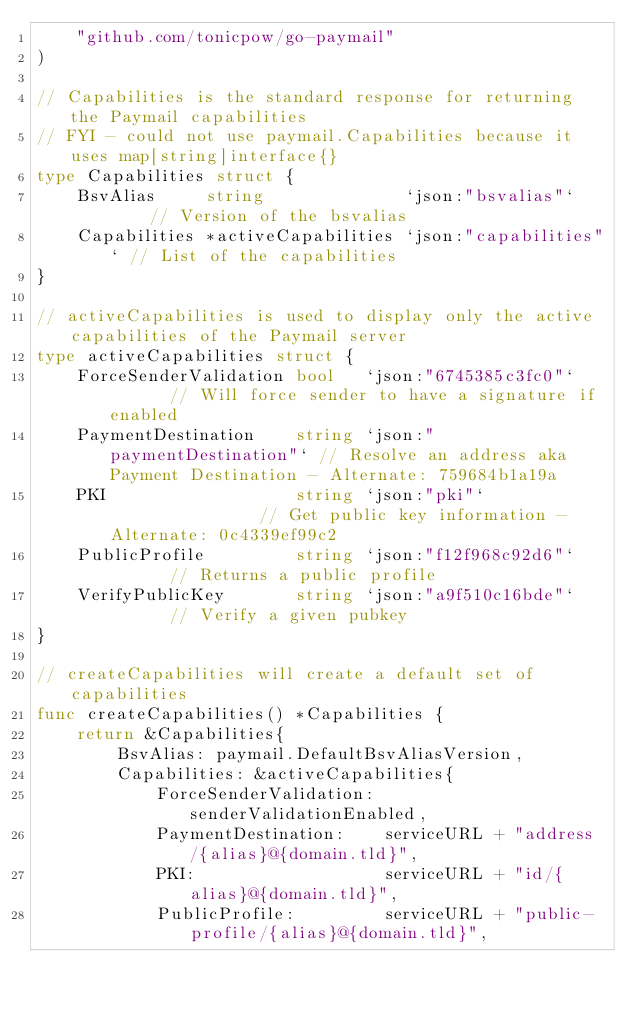Convert code to text. <code><loc_0><loc_0><loc_500><loc_500><_Go_>	"github.com/tonicpow/go-paymail"
)

// Capabilities is the standard response for returning the Paymail capabilities
// FYI - could not use paymail.Capabilities because it uses map[string]interface{}
type Capabilities struct {
	BsvAlias     string              `json:"bsvalias"`     // Version of the bsvalias
	Capabilities *activeCapabilities `json:"capabilities"` // List of the capabilities
}

// activeCapabilities is used to display only the active capabilities of the Paymail server
type activeCapabilities struct {
	ForceSenderValidation bool   `json:"6745385c3fc0"`       // Will force sender to have a signature if enabled
	PaymentDestination    string `json:"paymentDestination"` // Resolve an address aka Payment Destination - Alternate: 759684b1a19a
	PKI                   string `json:"pki"`                // Get public key information - Alternate: 0c4339ef99c2
	PublicProfile         string `json:"f12f968c92d6"`       // Returns a public profile
	VerifyPublicKey       string `json:"a9f510c16bde"`       // Verify a given pubkey
}

// createCapabilities will create a default set of capabilities
func createCapabilities() *Capabilities {
	return &Capabilities{
		BsvAlias: paymail.DefaultBsvAliasVersion,
		Capabilities: &activeCapabilities{
			ForceSenderValidation: senderValidationEnabled,
			PaymentDestination:    serviceURL + "address/{alias}@{domain.tld}",
			PKI:                   serviceURL + "id/{alias}@{domain.tld}",
			PublicProfile:         serviceURL + "public-profile/{alias}@{domain.tld}",</code> 